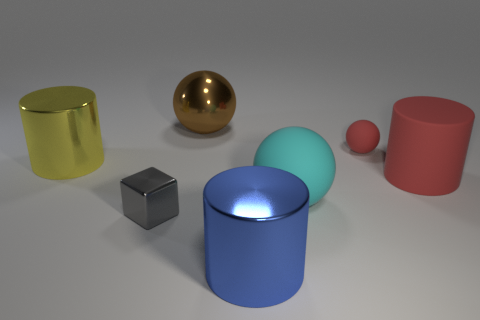How many other things are the same size as the brown metal object?
Make the answer very short. 4. There is a red thing to the left of the big red cylinder on the right side of the metal block; are there any large spheres behind it?
Your response must be concise. Yes. The cyan sphere has what size?
Keep it short and to the point. Large. There is a cylinder that is in front of the big red rubber thing; what is its size?
Ensure brevity in your answer.  Large. There is a thing that is in front of the gray shiny object; is its size the same as the red matte ball?
Your answer should be compact. No. Is there anything else that has the same color as the large matte sphere?
Keep it short and to the point. No. The gray thing is what shape?
Give a very brief answer. Cube. What number of cylinders are both left of the tiny red ball and behind the big blue shiny thing?
Ensure brevity in your answer.  1. Is the color of the metallic cube the same as the large matte cylinder?
Provide a succinct answer. No. There is a small red object that is the same shape as the large brown shiny thing; what material is it?
Offer a terse response. Rubber. 